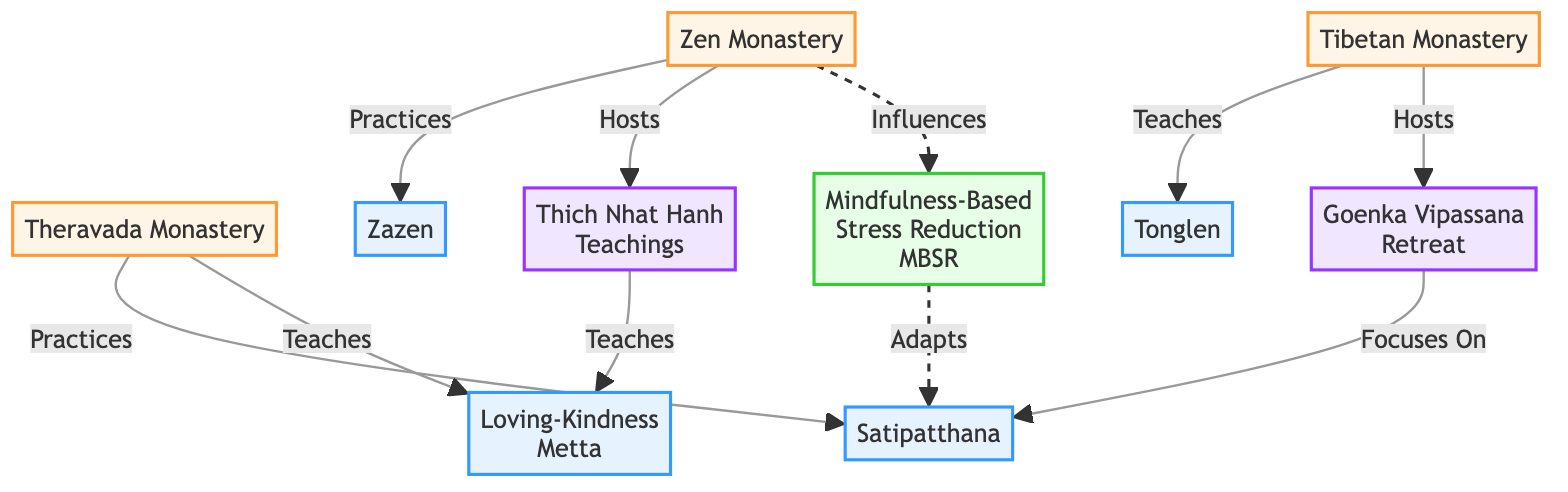What are the three traditions represented in the diagram? The diagram lists three nodes categorized as "Tradition": Theravada Monastery, Zen Monastery, and Tibetan Monastery.
Answer: Theravada Monastery, Zen Monastery, Tibetan Monastery Which mindfulness technique is associated with the Theravada Monastery? The edge connecting the Theravada Monastery to the Satipatthana node indicates that Theravada Monastery practices Satipatthana.
Answer: Satipatthana How many mindfulness techniques are shown in the diagram? There are four mindfulness techniques represented as nodes: Satipatthana, Zazen, Loving-Kindness (Metta), and Tonglen.
Answer: 4 Which event is hosted by the Zen Monastery? The diagram shows an edge from the Zen Monastery to Thich Nhat Hanh Teachings, indicating that it hosts this event.
Answer: Thich Nhat Hanh Teachings What type of relationship exists between the Zen Monastery and Mindfulness-Based Stress Reduction (MBSR)? The diagram displays a dashed edge from the Zen Monastery to MBSR, indicating an "influence." This suggests a more indirect association compared to other relationships.
Answer: Influences Which mindfulness technique does the Goenka Vipassana Retreat focus on? The arrow from the Goenka Vipassana Retreat to Satipatthana indicates that this event focuses on practicing Satipatthana.
Answer: Satipatthana How many edges are there in the diagram? Counting all the edges connecting the nodes, there are a total of eight directed connections between the nodes representing relationships.
Answer: 8 Which monastery teaches Tonglen? The edge from the Tibetan Monastery to the Tonglen node denotes that the Tibetan Monastery teaches this technique.
Answer: Tibetan Monastery What is the relationship between the Zen Monastery and Zazen? The direct edge from the Zen Monastery to Zazen indicates that the Zen Monastery practices this mindfulness technique.
Answer: Practices 